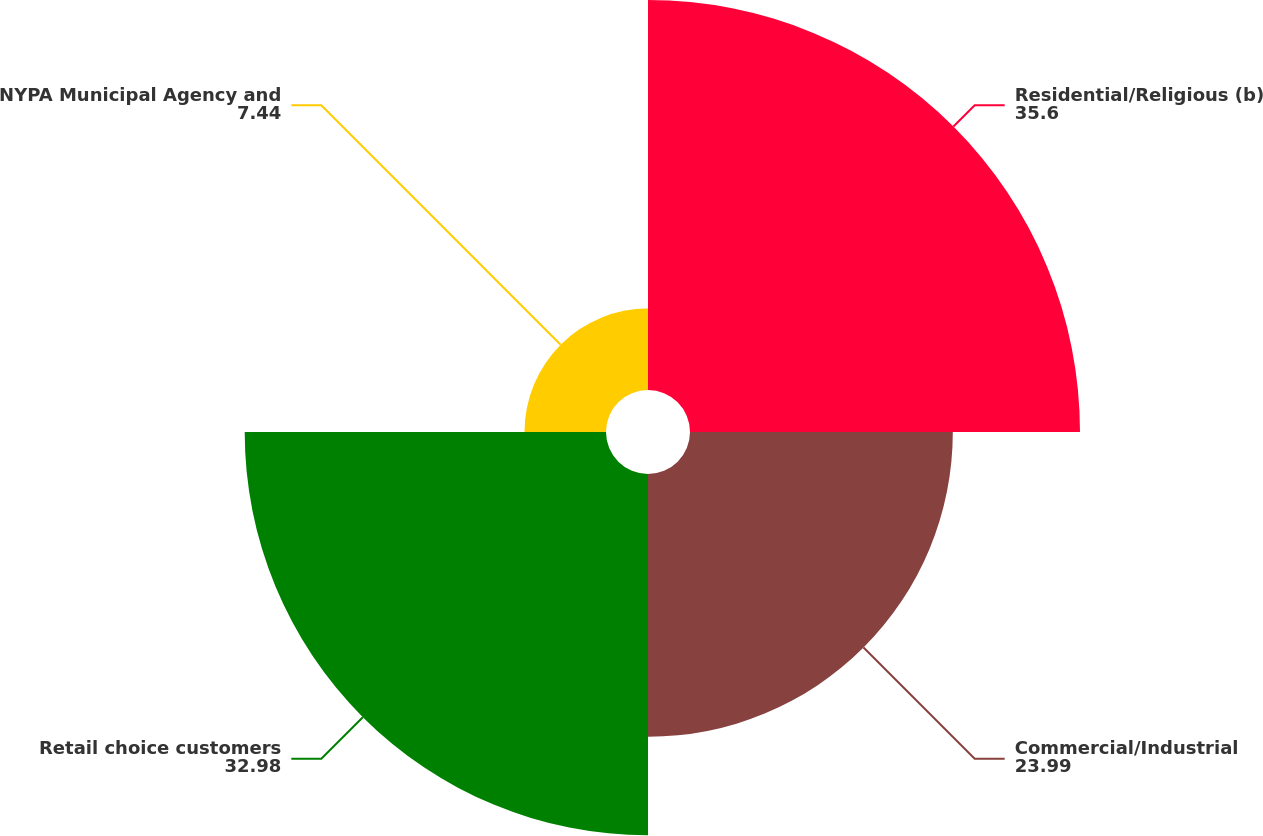<chart> <loc_0><loc_0><loc_500><loc_500><pie_chart><fcel>Residential/Religious (b)<fcel>Commercial/Industrial<fcel>Retail choice customers<fcel>NYPA Municipal Agency and<nl><fcel>35.6%<fcel>23.99%<fcel>32.98%<fcel>7.44%<nl></chart> 